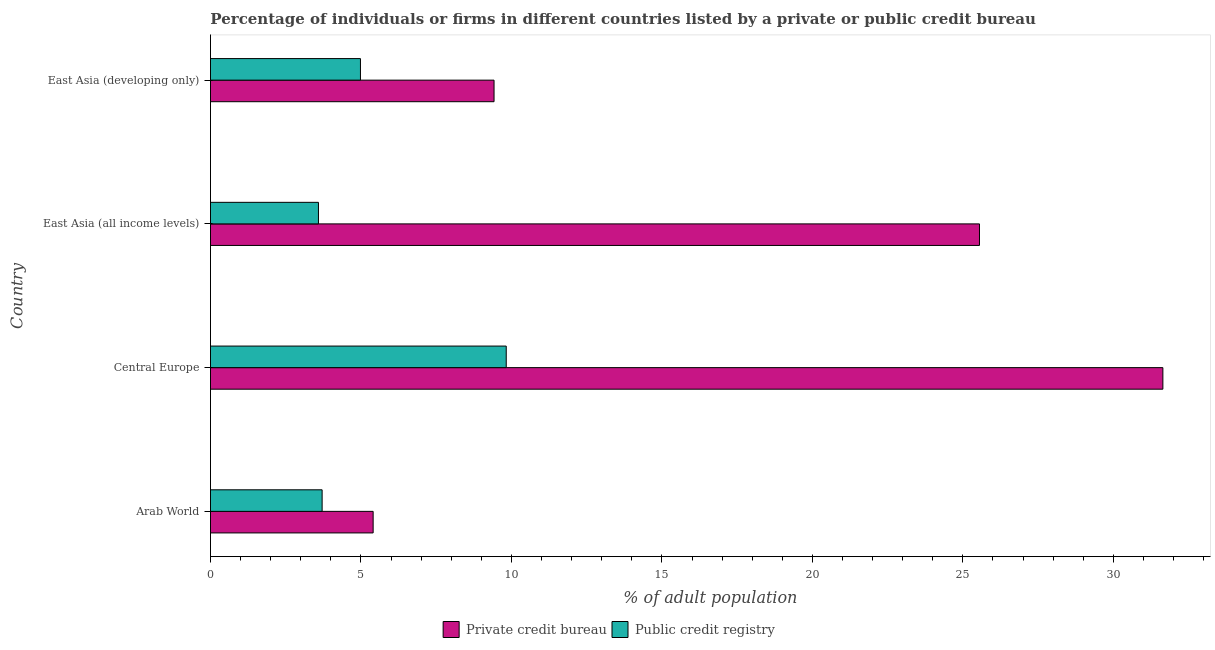How many different coloured bars are there?
Your answer should be compact. 2. How many groups of bars are there?
Provide a succinct answer. 4. Are the number of bars per tick equal to the number of legend labels?
Provide a short and direct response. Yes. Are the number of bars on each tick of the Y-axis equal?
Keep it short and to the point. Yes. How many bars are there on the 4th tick from the top?
Your response must be concise. 2. What is the label of the 4th group of bars from the top?
Ensure brevity in your answer.  Arab World. In how many cases, is the number of bars for a given country not equal to the number of legend labels?
Offer a terse response. 0. What is the percentage of firms listed by private credit bureau in East Asia (all income levels)?
Offer a terse response. 25.55. Across all countries, what is the maximum percentage of firms listed by public credit bureau?
Provide a short and direct response. 9.83. Across all countries, what is the minimum percentage of firms listed by private credit bureau?
Provide a short and direct response. 5.41. In which country was the percentage of firms listed by private credit bureau maximum?
Your response must be concise. Central Europe. In which country was the percentage of firms listed by private credit bureau minimum?
Give a very brief answer. Arab World. What is the total percentage of firms listed by public credit bureau in the graph?
Ensure brevity in your answer.  22.11. What is the difference between the percentage of firms listed by private credit bureau in Central Europe and that in East Asia (all income levels)?
Your answer should be compact. 6.09. What is the difference between the percentage of firms listed by private credit bureau in Central Europe and the percentage of firms listed by public credit bureau in East Asia (developing only)?
Your response must be concise. 26.66. What is the average percentage of firms listed by private credit bureau per country?
Make the answer very short. 18.01. What is the difference between the percentage of firms listed by private credit bureau and percentage of firms listed by public credit bureau in East Asia (all income levels)?
Make the answer very short. 21.96. In how many countries, is the percentage of firms listed by private credit bureau greater than 7 %?
Your answer should be very brief. 3. What is the ratio of the percentage of firms listed by public credit bureau in Central Europe to that in East Asia (developing only)?
Ensure brevity in your answer.  1.97. Is the percentage of firms listed by public credit bureau in Central Europe less than that in East Asia (developing only)?
Provide a succinct answer. No. Is the difference between the percentage of firms listed by public credit bureau in Central Europe and East Asia (all income levels) greater than the difference between the percentage of firms listed by private credit bureau in Central Europe and East Asia (all income levels)?
Your answer should be very brief. Yes. What is the difference between the highest and the second highest percentage of firms listed by private credit bureau?
Ensure brevity in your answer.  6.09. What is the difference between the highest and the lowest percentage of firms listed by public credit bureau?
Provide a short and direct response. 6.24. In how many countries, is the percentage of firms listed by private credit bureau greater than the average percentage of firms listed by private credit bureau taken over all countries?
Provide a succinct answer. 2. What does the 2nd bar from the top in East Asia (all income levels) represents?
Offer a very short reply. Private credit bureau. What does the 1st bar from the bottom in Arab World represents?
Provide a short and direct response. Private credit bureau. How many bars are there?
Provide a short and direct response. 8. What is the difference between two consecutive major ticks on the X-axis?
Keep it short and to the point. 5. Where does the legend appear in the graph?
Give a very brief answer. Bottom center. What is the title of the graph?
Your response must be concise. Percentage of individuals or firms in different countries listed by a private or public credit bureau. Does "Electricity" appear as one of the legend labels in the graph?
Your response must be concise. No. What is the label or title of the X-axis?
Your answer should be compact. % of adult population. What is the % of adult population in Private credit bureau in Arab World?
Provide a short and direct response. 5.41. What is the % of adult population in Public credit registry in Arab World?
Offer a terse response. 3.71. What is the % of adult population of Private credit bureau in Central Europe?
Make the answer very short. 31.65. What is the % of adult population in Public credit registry in Central Europe?
Provide a succinct answer. 9.83. What is the % of adult population in Private credit bureau in East Asia (all income levels)?
Offer a terse response. 25.55. What is the % of adult population of Public credit registry in East Asia (all income levels)?
Your answer should be very brief. 3.59. What is the % of adult population of Private credit bureau in East Asia (developing only)?
Offer a very short reply. 9.42. What is the % of adult population in Public credit registry in East Asia (developing only)?
Ensure brevity in your answer.  4.98. Across all countries, what is the maximum % of adult population of Private credit bureau?
Ensure brevity in your answer.  31.65. Across all countries, what is the maximum % of adult population of Public credit registry?
Your answer should be compact. 9.83. Across all countries, what is the minimum % of adult population in Private credit bureau?
Give a very brief answer. 5.41. Across all countries, what is the minimum % of adult population of Public credit registry?
Offer a terse response. 3.59. What is the total % of adult population of Private credit bureau in the graph?
Your answer should be compact. 72.02. What is the total % of adult population of Public credit registry in the graph?
Give a very brief answer. 22.11. What is the difference between the % of adult population in Private credit bureau in Arab World and that in Central Europe?
Offer a very short reply. -26.24. What is the difference between the % of adult population in Public credit registry in Arab World and that in Central Europe?
Provide a succinct answer. -6.12. What is the difference between the % of adult population in Private credit bureau in Arab World and that in East Asia (all income levels)?
Make the answer very short. -20.15. What is the difference between the % of adult population of Public credit registry in Arab World and that in East Asia (all income levels)?
Your answer should be compact. 0.12. What is the difference between the % of adult population of Private credit bureau in Arab World and that in East Asia (developing only)?
Your answer should be very brief. -4.02. What is the difference between the % of adult population in Public credit registry in Arab World and that in East Asia (developing only)?
Make the answer very short. -1.27. What is the difference between the % of adult population in Private credit bureau in Central Europe and that in East Asia (all income levels)?
Offer a terse response. 6.09. What is the difference between the % of adult population in Public credit registry in Central Europe and that in East Asia (all income levels)?
Give a very brief answer. 6.24. What is the difference between the % of adult population of Private credit bureau in Central Europe and that in East Asia (developing only)?
Ensure brevity in your answer.  22.22. What is the difference between the % of adult population of Public credit registry in Central Europe and that in East Asia (developing only)?
Give a very brief answer. 4.84. What is the difference between the % of adult population of Private credit bureau in East Asia (all income levels) and that in East Asia (developing only)?
Provide a short and direct response. 16.13. What is the difference between the % of adult population in Public credit registry in East Asia (all income levels) and that in East Asia (developing only)?
Offer a terse response. -1.4. What is the difference between the % of adult population in Private credit bureau in Arab World and the % of adult population in Public credit registry in Central Europe?
Your response must be concise. -4.42. What is the difference between the % of adult population of Private credit bureau in Arab World and the % of adult population of Public credit registry in East Asia (all income levels)?
Provide a short and direct response. 1.82. What is the difference between the % of adult population in Private credit bureau in Arab World and the % of adult population in Public credit registry in East Asia (developing only)?
Offer a terse response. 0.42. What is the difference between the % of adult population in Private credit bureau in Central Europe and the % of adult population in Public credit registry in East Asia (all income levels)?
Provide a short and direct response. 28.06. What is the difference between the % of adult population of Private credit bureau in Central Europe and the % of adult population of Public credit registry in East Asia (developing only)?
Your response must be concise. 26.66. What is the difference between the % of adult population in Private credit bureau in East Asia (all income levels) and the % of adult population in Public credit registry in East Asia (developing only)?
Your answer should be very brief. 20.57. What is the average % of adult population in Private credit bureau per country?
Provide a succinct answer. 18.01. What is the average % of adult population in Public credit registry per country?
Provide a succinct answer. 5.53. What is the difference between the % of adult population in Private credit bureau and % of adult population in Public credit registry in Arab World?
Offer a very short reply. 1.7. What is the difference between the % of adult population in Private credit bureau and % of adult population in Public credit registry in Central Europe?
Provide a succinct answer. 21.82. What is the difference between the % of adult population in Private credit bureau and % of adult population in Public credit registry in East Asia (all income levels)?
Your answer should be compact. 21.96. What is the difference between the % of adult population of Private credit bureau and % of adult population of Public credit registry in East Asia (developing only)?
Give a very brief answer. 4.44. What is the ratio of the % of adult population of Private credit bureau in Arab World to that in Central Europe?
Give a very brief answer. 0.17. What is the ratio of the % of adult population in Public credit registry in Arab World to that in Central Europe?
Keep it short and to the point. 0.38. What is the ratio of the % of adult population of Private credit bureau in Arab World to that in East Asia (all income levels)?
Provide a short and direct response. 0.21. What is the ratio of the % of adult population of Public credit registry in Arab World to that in East Asia (all income levels)?
Provide a succinct answer. 1.03. What is the ratio of the % of adult population of Private credit bureau in Arab World to that in East Asia (developing only)?
Your response must be concise. 0.57. What is the ratio of the % of adult population in Public credit registry in Arab World to that in East Asia (developing only)?
Make the answer very short. 0.74. What is the ratio of the % of adult population of Private credit bureau in Central Europe to that in East Asia (all income levels)?
Ensure brevity in your answer.  1.24. What is the ratio of the % of adult population of Public credit registry in Central Europe to that in East Asia (all income levels)?
Keep it short and to the point. 2.74. What is the ratio of the % of adult population in Private credit bureau in Central Europe to that in East Asia (developing only)?
Your response must be concise. 3.36. What is the ratio of the % of adult population in Public credit registry in Central Europe to that in East Asia (developing only)?
Keep it short and to the point. 1.97. What is the ratio of the % of adult population in Private credit bureau in East Asia (all income levels) to that in East Asia (developing only)?
Offer a terse response. 2.71. What is the ratio of the % of adult population of Public credit registry in East Asia (all income levels) to that in East Asia (developing only)?
Keep it short and to the point. 0.72. What is the difference between the highest and the second highest % of adult population of Private credit bureau?
Ensure brevity in your answer.  6.09. What is the difference between the highest and the second highest % of adult population of Public credit registry?
Your answer should be very brief. 4.84. What is the difference between the highest and the lowest % of adult population in Private credit bureau?
Ensure brevity in your answer.  26.24. What is the difference between the highest and the lowest % of adult population of Public credit registry?
Give a very brief answer. 6.24. 